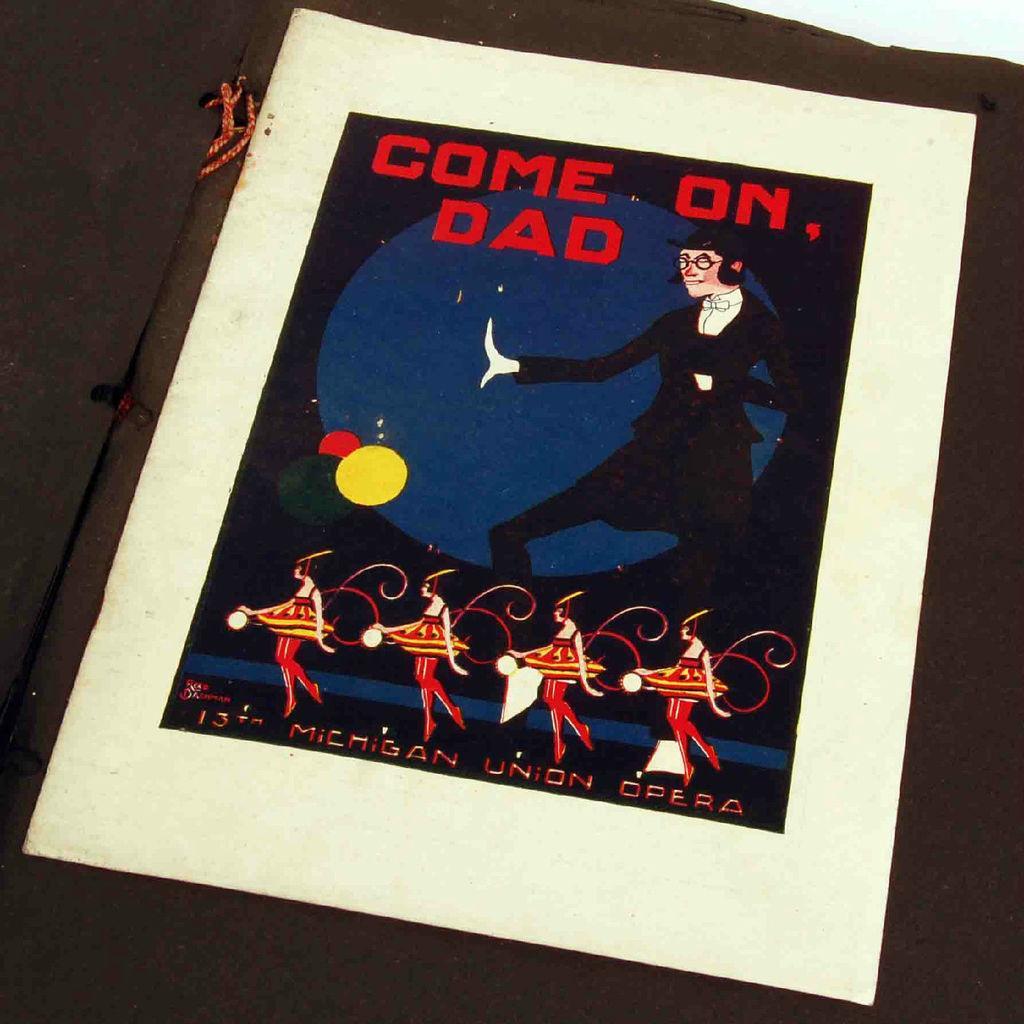Describe this image in one or two sentences. In the image there is a black paper on which boundaries are made with white colour and there is written "Come On Dad". A circle in between which is filled with blue colour and a person standing beside it wearing glasses. Four girls are dancing and there is written "13th Michigan Union Opera". 